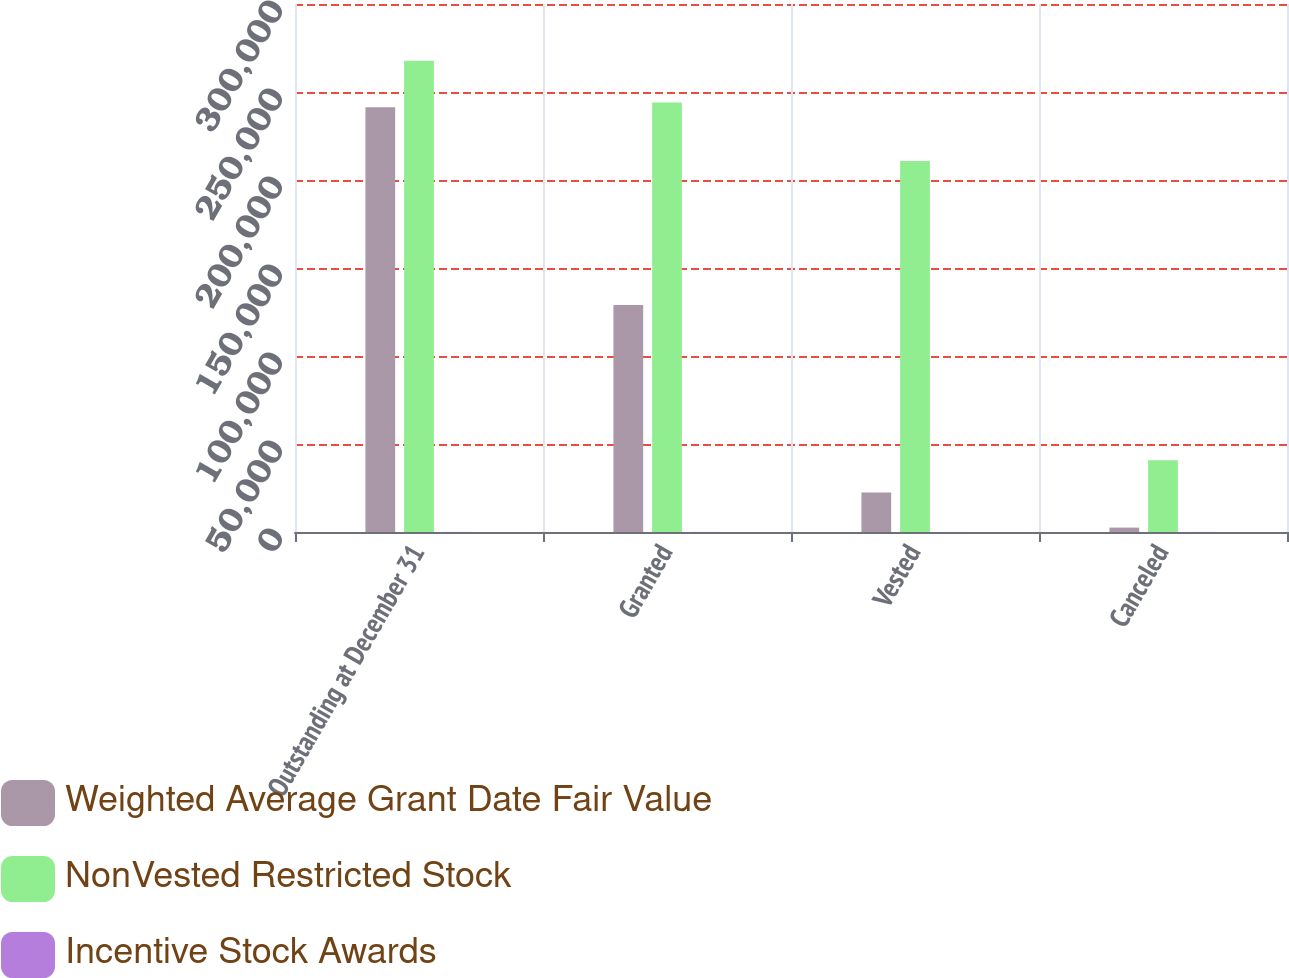Convert chart to OTSL. <chart><loc_0><loc_0><loc_500><loc_500><stacked_bar_chart><ecel><fcel>Outstanding at December 31<fcel>Granted<fcel>Vested<fcel>Canceled<nl><fcel>Weighted Average Grant Date Fair Value<fcel>241284<fcel>129000<fcel>22500<fcel>2500<nl><fcel>NonVested Restricted Stock<fcel>267792<fcel>244000<fcel>210843<fcel>40774<nl><fcel>Incentive Stock Awards<fcel>31.65<fcel>34.08<fcel>17.97<fcel>21.37<nl></chart> 